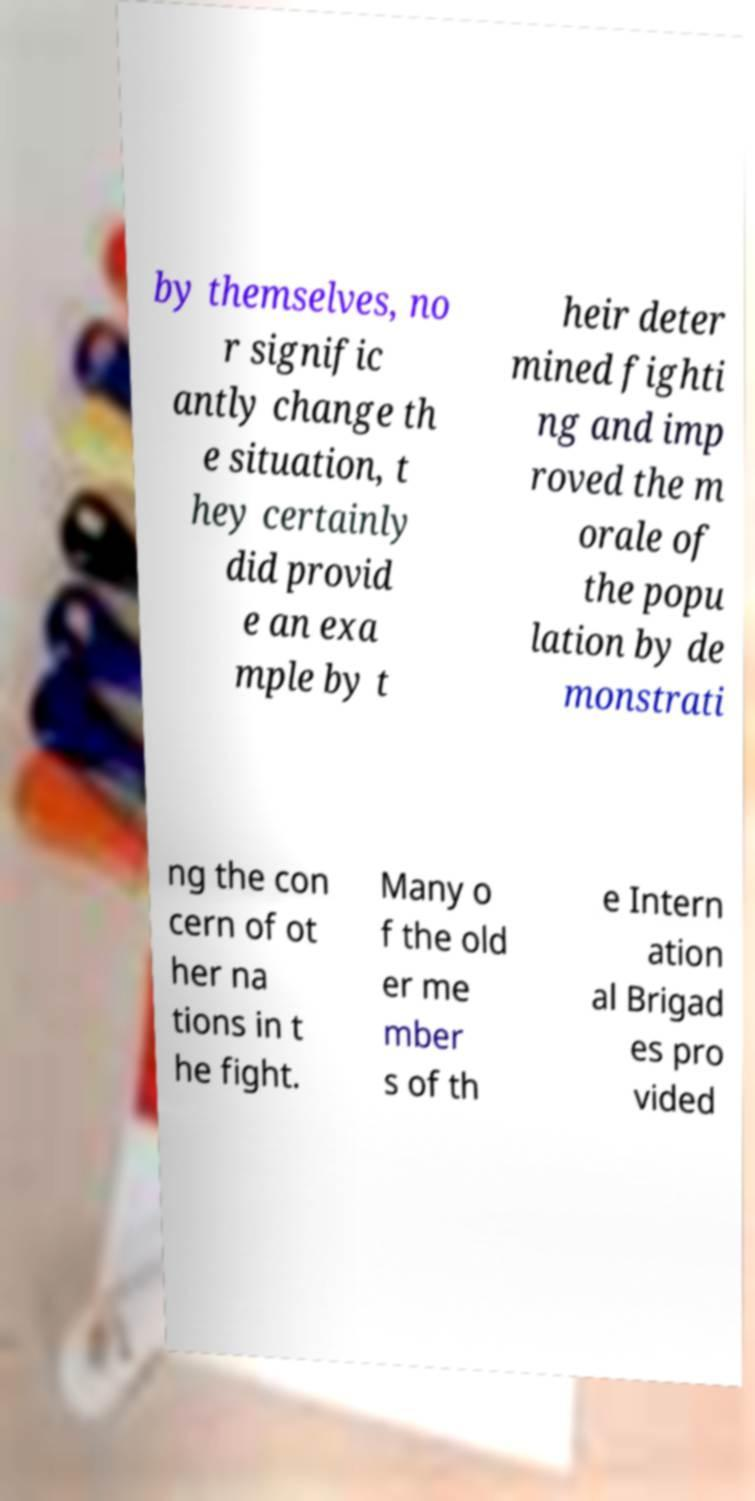Can you accurately transcribe the text from the provided image for me? by themselves, no r signific antly change th e situation, t hey certainly did provid e an exa mple by t heir deter mined fighti ng and imp roved the m orale of the popu lation by de monstrati ng the con cern of ot her na tions in t he fight. Many o f the old er me mber s of th e Intern ation al Brigad es pro vided 